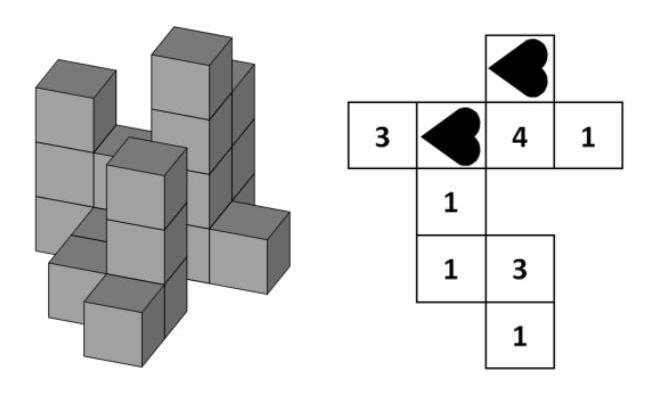Max builds this construction using some small equally big cubes. If he looks at his construction from above, the plan on the right tells the number of cubes in every tower. How big is the sum of the numbers covered by the two hearts? The sum of the numbers covered by the two hearts in the image is 5. This is calculated by adding the numbers presented in the two cells of the plan corresponding to where the hearts are located, which are 3 and 1, plus 1, from a different cell also covered by a heart, resulting in a total of 5 cubes. 